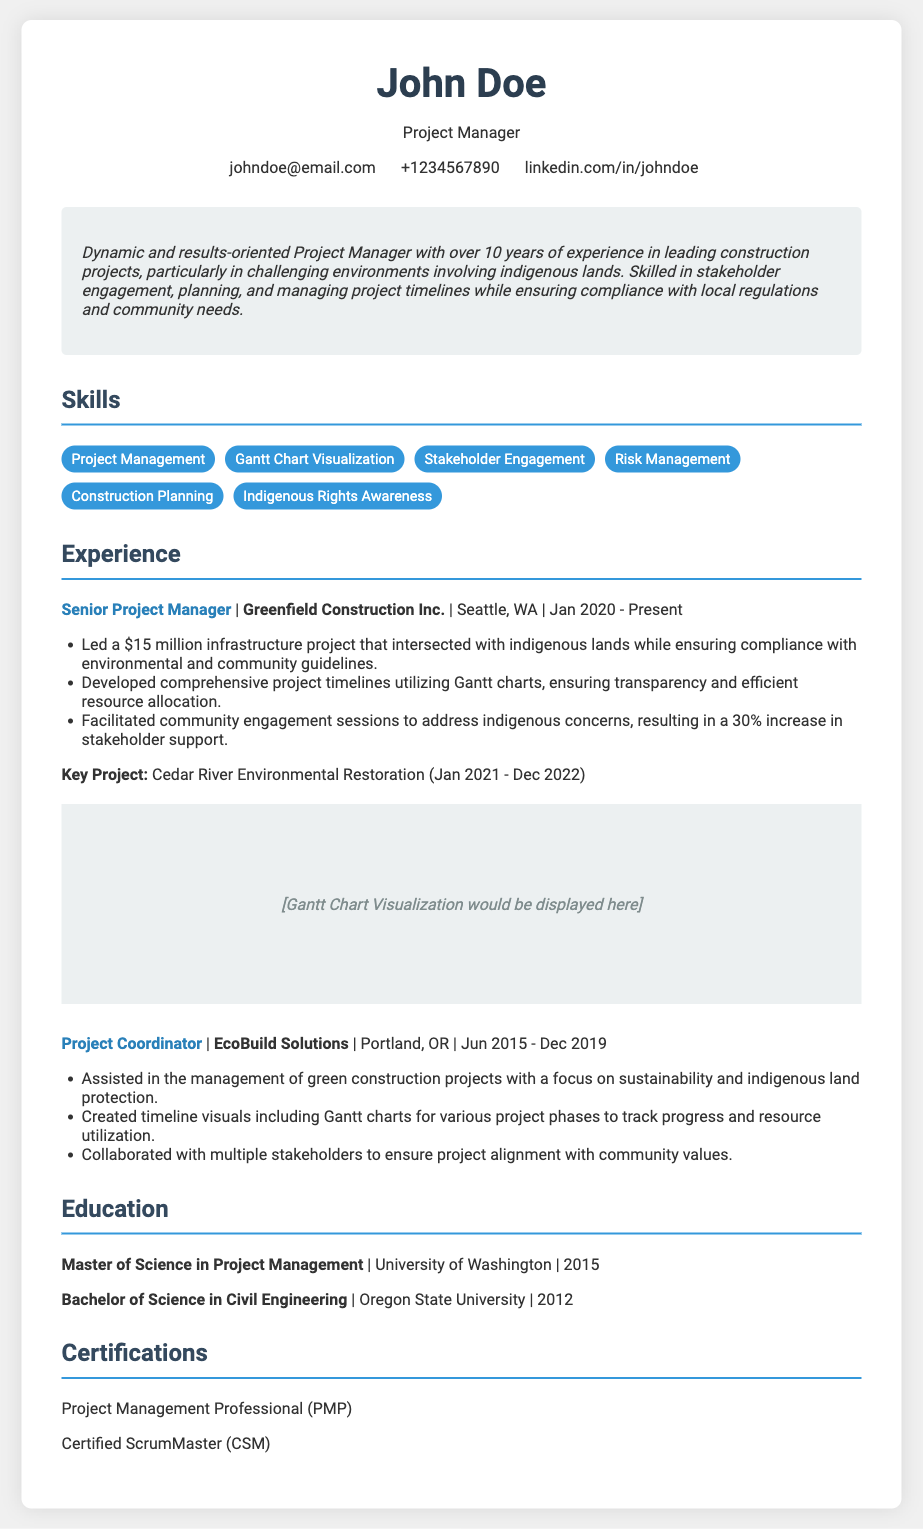what is the name of the project manager? The name listed at the top of the document is John Doe, who holds the title of Project Manager.
Answer: John Doe what is the contact email of John Doe? The document provides an email address in the contact info section, which is johndoe@email.com.
Answer: johndoe@email.com where is Greenfield Construction Inc. located? The document shows that Greenfield Construction Inc. is located in Seattle, WA.
Answer: Seattle, WA what is the duration of the Cedar River Environmental Restoration project? The project duration is specified from January 2021 to December 2022, indicating a two-year timeline.
Answer: Jan 2021 - Dec 2022 how much was the budget for the infrastructure project? The budget for the infrastructure project led by John Doe is mentioned as $15 million.
Answer: $15 million what type of chart was utilized for project timelines? The document states that Gantt charts were used to visualize project timelines.
Answer: Gantt charts what is one key achievement from John Doe's experience? A notable achievement mentioned is a 30% increase in stakeholder support due to facilitated community engagement sessions.
Answer: 30% increase in stakeholder support which degree did John Doe earn in 2015? The document lists a Master of Science in Project Management as John Doe's degree earned in 2015.
Answer: Master of Science in Project Management what is a key focus in the projects managed by John Doe? John Doe's projects emphasize stakeholder engagement and compliance with community needs and regulations.
Answer: Stakeholder engagement 